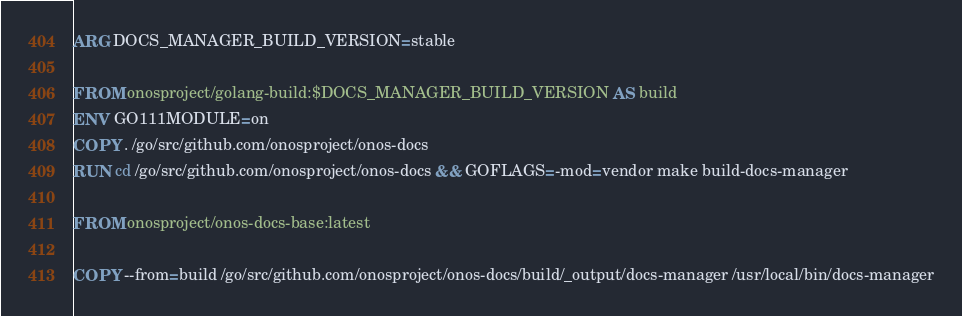Convert code to text. <code><loc_0><loc_0><loc_500><loc_500><_Dockerfile_>ARG DOCS_MANAGER_BUILD_VERSION=stable

FROM onosproject/golang-build:$DOCS_MANAGER_BUILD_VERSION AS build
ENV GO111MODULE=on
COPY . /go/src/github.com/onosproject/onos-docs
RUN cd /go/src/github.com/onosproject/onos-docs && GOFLAGS=-mod=vendor make build-docs-manager

FROM onosproject/onos-docs-base:latest

COPY --from=build /go/src/github.com/onosproject/onos-docs/build/_output/docs-manager /usr/local/bin/docs-manager

</code> 